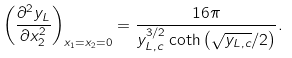Convert formula to latex. <formula><loc_0><loc_0><loc_500><loc_500>\left ( \frac { \partial ^ { 2 } y _ { L } } { \partial x _ { 2 } ^ { 2 } } \right ) _ { x _ { 1 } = x _ { 2 } = 0 } = \frac { 1 6 \pi } { y _ { L , c } ^ { 3 / 2 } \coth \left ( \sqrt { y _ { L , c } } / 2 \right ) } .</formula> 